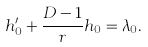Convert formula to latex. <formula><loc_0><loc_0><loc_500><loc_500>h _ { 0 } ^ { \prime } + \frac { D - 1 } { r } h _ { 0 } = \lambda _ { 0 } .</formula> 